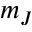Convert formula to latex. <formula><loc_0><loc_0><loc_500><loc_500>m _ { J }</formula> 